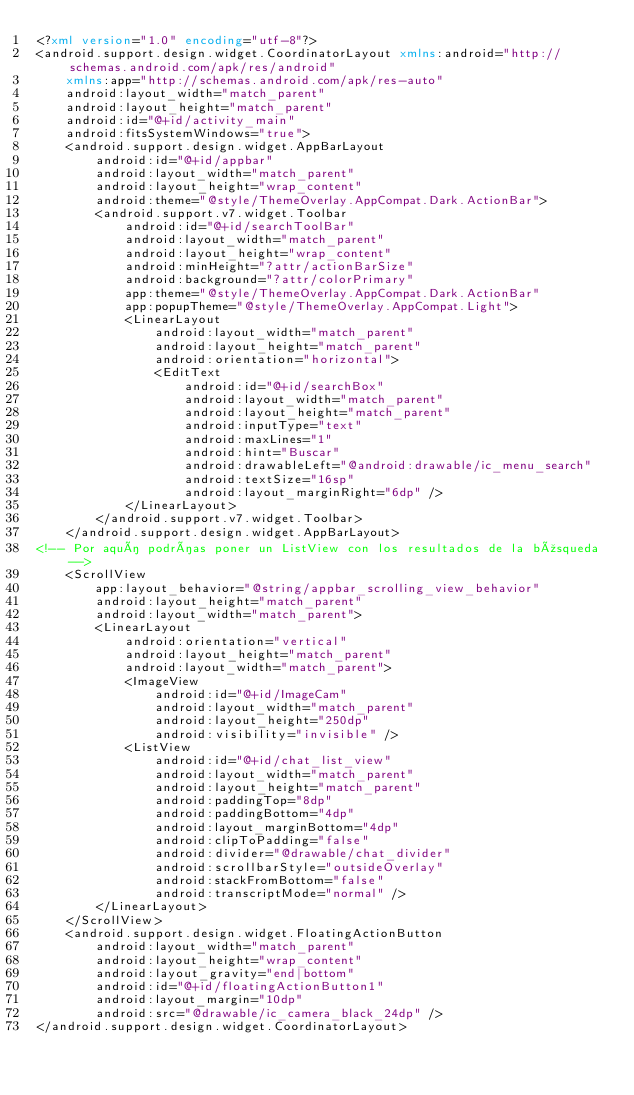<code> <loc_0><loc_0><loc_500><loc_500><_XML_><?xml version="1.0" encoding="utf-8"?>
<android.support.design.widget.CoordinatorLayout xmlns:android="http://schemas.android.com/apk/res/android"
    xmlns:app="http://schemas.android.com/apk/res-auto"
    android:layout_width="match_parent"
    android:layout_height="match_parent"
    android:id="@+id/activity_main"
    android:fitsSystemWindows="true">
    <android.support.design.widget.AppBarLayout
        android:id="@+id/appbar"
        android:layout_width="match_parent"
        android:layout_height="wrap_content"
        android:theme="@style/ThemeOverlay.AppCompat.Dark.ActionBar">
        <android.support.v7.widget.Toolbar
            android:id="@+id/searchToolBar"
            android:layout_width="match_parent"
            android:layout_height="wrap_content"
            android:minHeight="?attr/actionBarSize"
            android:background="?attr/colorPrimary"
            app:theme="@style/ThemeOverlay.AppCompat.Dark.ActionBar"
            app:popupTheme="@style/ThemeOverlay.AppCompat.Light">
            <LinearLayout
                android:layout_width="match_parent"
                android:layout_height="match_parent"
                android:orientation="horizontal">
                <EditText
                    android:id="@+id/searchBox"
                    android:layout_width="match_parent"
                    android:layout_height="match_parent"
                    android:inputType="text"
                    android:maxLines="1"
                    android:hint="Buscar"
                    android:drawableLeft="@android:drawable/ic_menu_search"
                    android:textSize="16sp"
                    android:layout_marginRight="6dp" />
            </LinearLayout>
        </android.support.v7.widget.Toolbar>
    </android.support.design.widget.AppBarLayout>
<!-- Por aquí podrías poner un ListView con los resultados de la búsqueda -->
    <ScrollView
        app:layout_behavior="@string/appbar_scrolling_view_behavior"
        android:layout_height="match_parent"
        android:layout_width="match_parent">
        <LinearLayout
            android:orientation="vertical"
            android:layout_height="match_parent"
            android:layout_width="match_parent">
            <ImageView
                android:id="@+id/ImageCam"
                android:layout_width="match_parent"
                android:layout_height="250dp"
                android:visibility="invisible" />
            <ListView
                android:id="@+id/chat_list_view"
                android:layout_width="match_parent"
                android:layout_height="match_parent"
                android:paddingTop="8dp"
                android:paddingBottom="4dp"
                android:layout_marginBottom="4dp"
                android:clipToPadding="false"
                android:divider="@drawable/chat_divider"
                android:scrollbarStyle="outsideOverlay"
                android:stackFromBottom="false"
                android:transcriptMode="normal" />
        </LinearLayout>
    </ScrollView>
    <android.support.design.widget.FloatingActionButton
        android:layout_width="match_parent"
        android:layout_height="wrap_content"
        android:layout_gravity="end|bottom"
        android:id="@+id/floatingActionButton1"
        android:layout_margin="10dp"
        android:src="@drawable/ic_camera_black_24dp" />
</android.support.design.widget.CoordinatorLayout></code> 